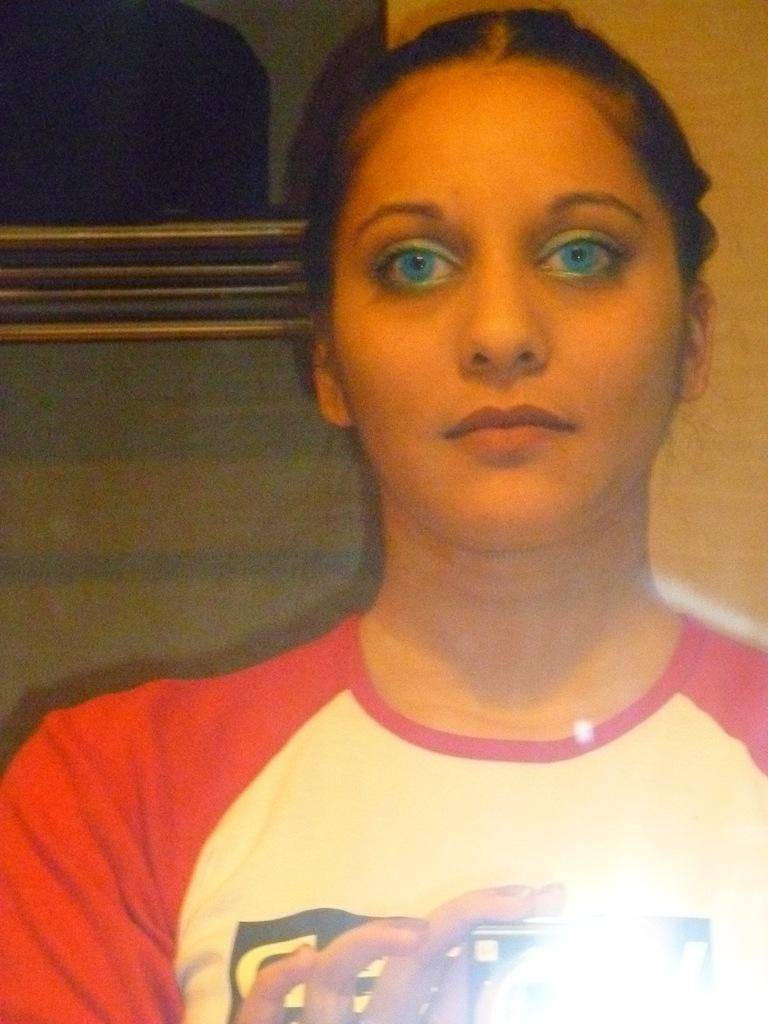Who is the main subject in the picture? There is a woman in the picture. What is the woman wearing? The woman is wearing a t-shirt. What is the woman holding in the picture? The woman is holding a camera. Can you describe the lighting in the image? There is a light in the bottom right corner of the image. What type of carriage can be seen in the background of the image? There is no carriage present in the image. Can you tell me the color of the cat in the image? There is no cat present in the image. 